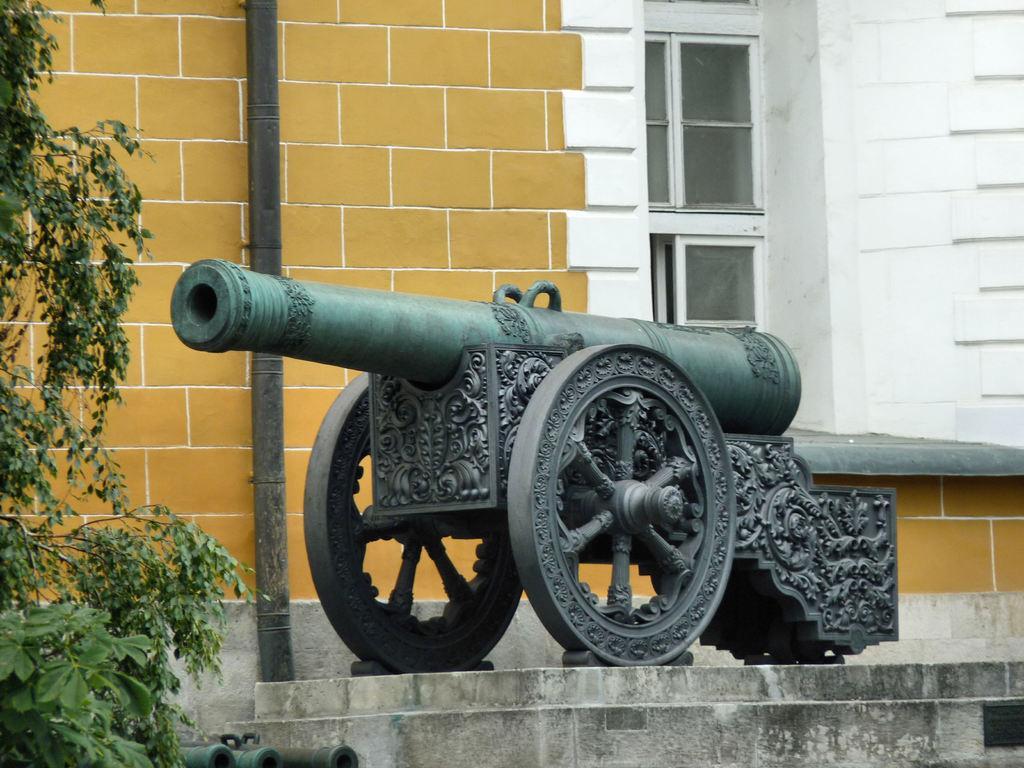In one or two sentences, can you explain what this image depicts? In this image we can see a cannon on an object. On the left side of the image there is a tree and an object. In the background of the image there is a wall, glass window and an iron object. 